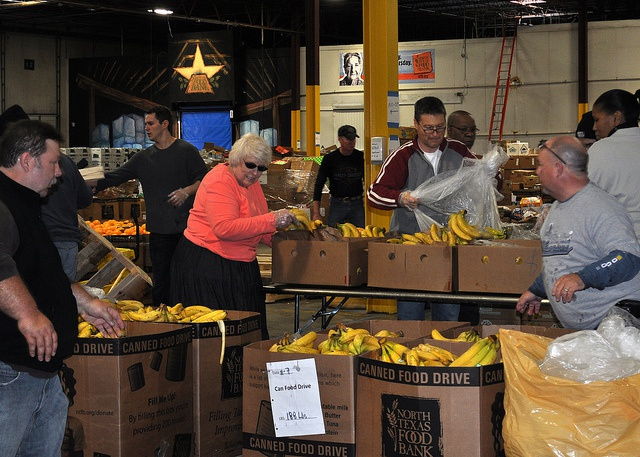Describe the objects in this image and their specific colors. I can see people in black, gray, brown, and darkblue tones, people in black, gray, and brown tones, people in black, salmon, and brown tones, banana in black, maroon, and olive tones, and people in black, brown, and maroon tones in this image. 